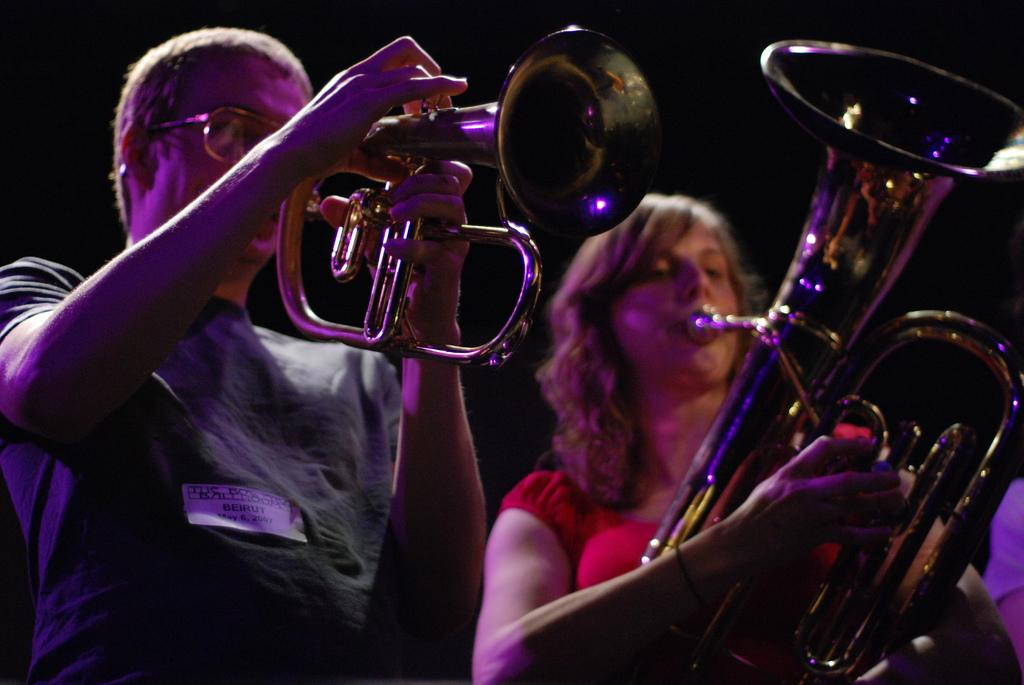How many people are in the image? There are people in the image, but the exact number is not specified. What are the people doing in the image? The people are standing and playing musical instruments. Can you describe the actions of the people in the image? The people are standing and playing musical instruments, which suggests they might be part of a band or performance. What type of wool is being used to create the sound from the musical instruments in the image? There is no wool mentioned or depicted in the image, and the musical instruments do not require wool to produce sound. 